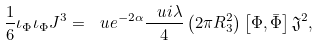<formula> <loc_0><loc_0><loc_500><loc_500>\frac { 1 } { 6 } \iota _ { \Phi } \iota _ { \Phi } J ^ { 3 } = \ u e ^ { - 2 \alpha } \frac { \ u i \lambda } { 4 } \left ( 2 \pi R _ { 3 } ^ { 2 } \right ) \left [ \Phi , \bar { \Phi } \right ] \mathfrak { J } ^ { 2 } ,</formula> 